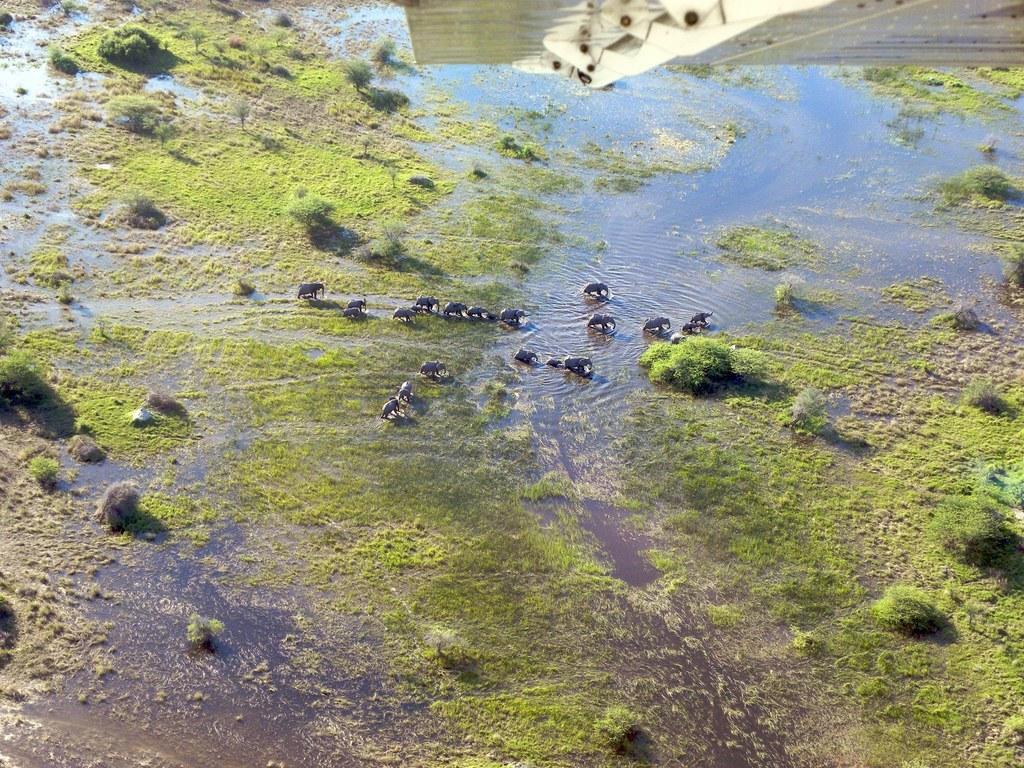Could you give a brief overview of what you see in this image? The picture is an aerial view of a water body. In the center of the picture we can see elephants. In this picture there are plants, grass and water. 